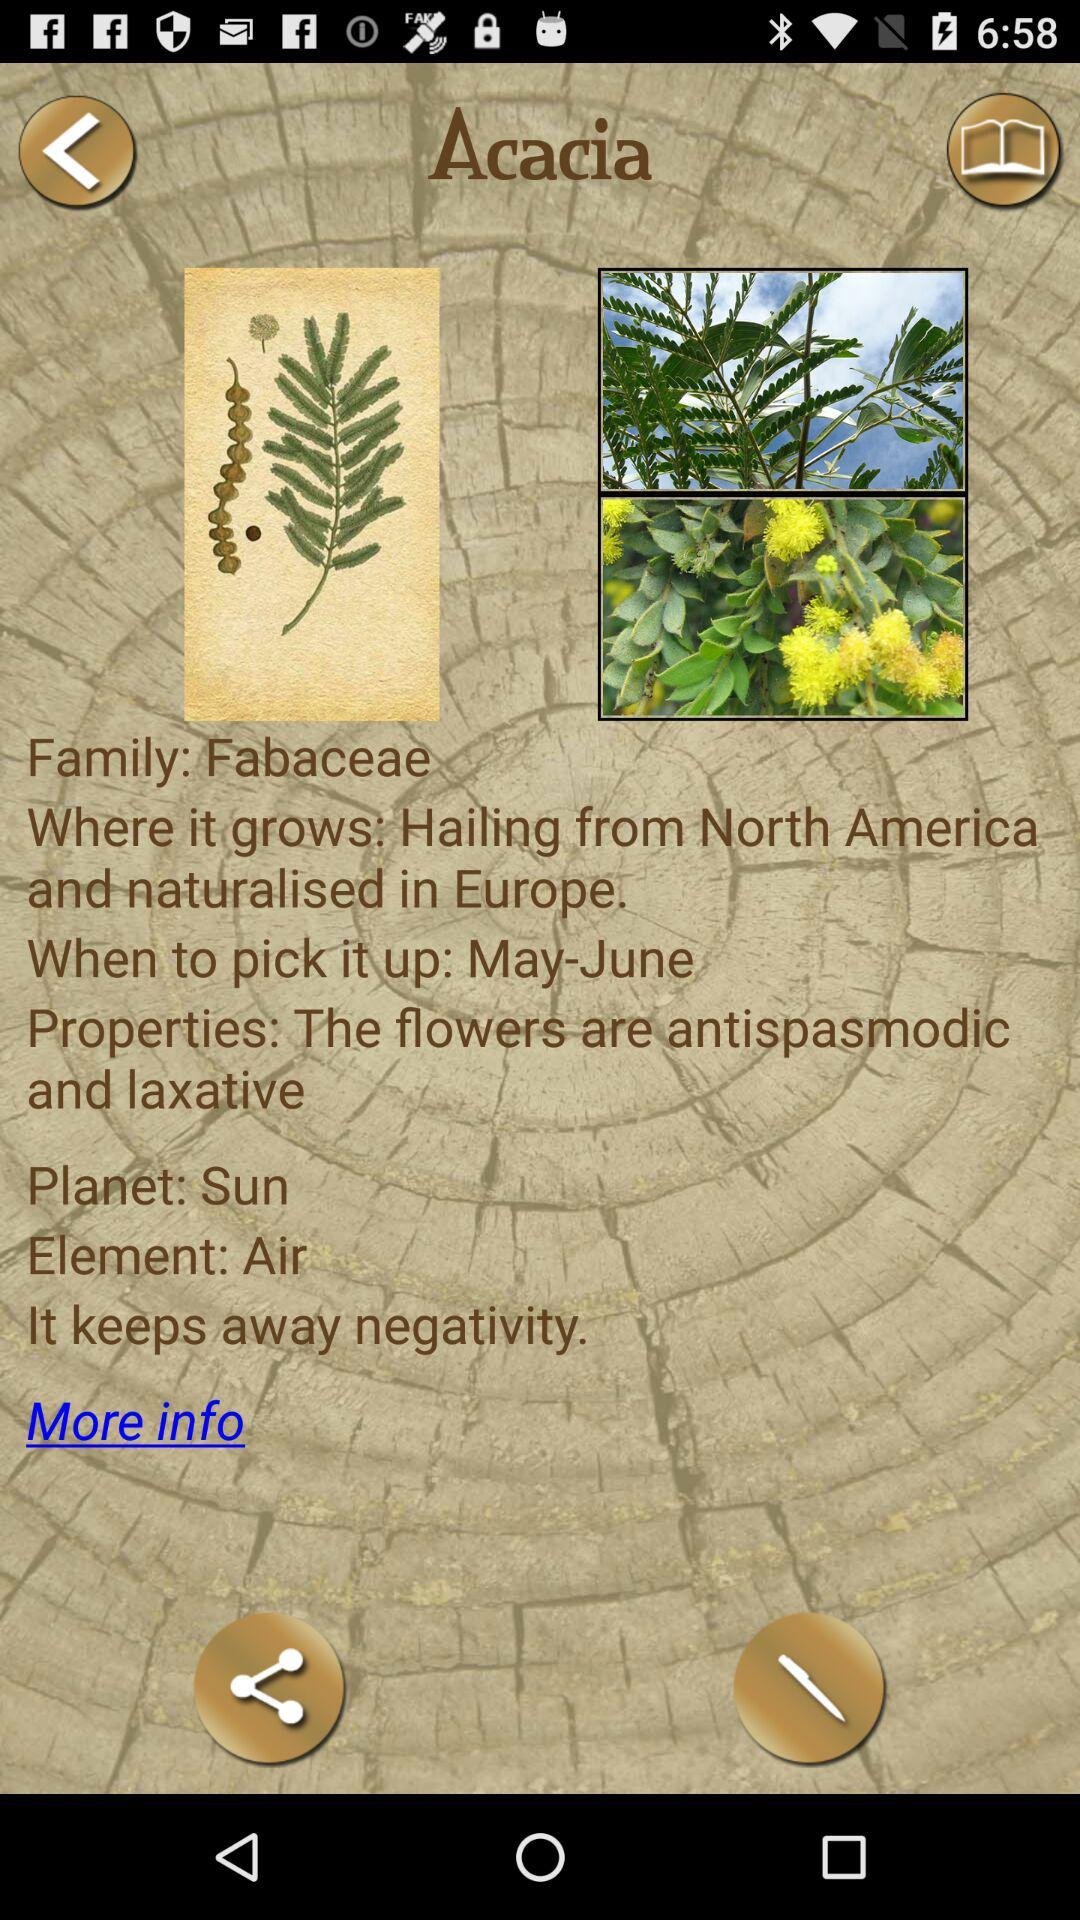What are the properties of Acacia? The properties are "The flowers are antispasmodic and laxative". 